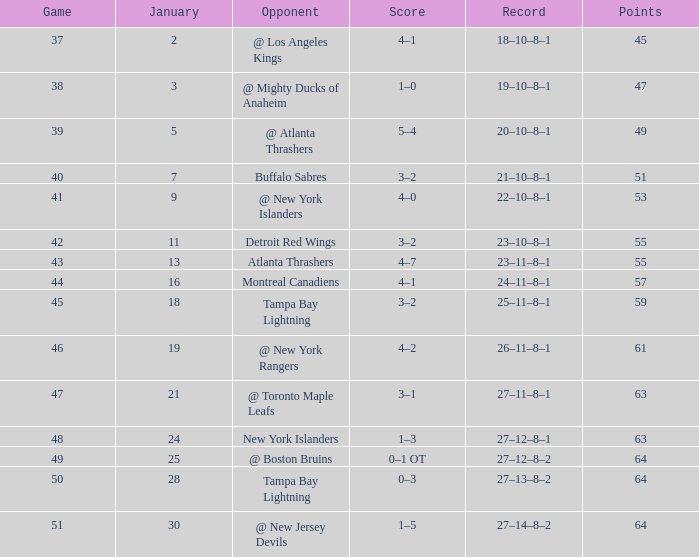Give me the full table as a dictionary. {'header': ['Game', 'January', 'Opponent', 'Score', 'Record', 'Points'], 'rows': [['37', '2', '@ Los Angeles Kings', '4–1', '18–10–8–1', '45'], ['38', '3', '@ Mighty Ducks of Anaheim', '1–0', '19–10–8–1', '47'], ['39', '5', '@ Atlanta Thrashers', '5–4', '20–10–8–1', '49'], ['40', '7', 'Buffalo Sabres', '3–2', '21–10–8–1', '51'], ['41', '9', '@ New York Islanders', '4–0', '22–10–8–1', '53'], ['42', '11', 'Detroit Red Wings', '3–2', '23–10–8–1', '55'], ['43', '13', 'Atlanta Thrashers', '4–7', '23–11–8–1', '55'], ['44', '16', 'Montreal Canadiens', '4–1', '24–11–8–1', '57'], ['45', '18', 'Tampa Bay Lightning', '3–2', '25–11–8–1', '59'], ['46', '19', '@ New York Rangers', '4–2', '26–11–8–1', '61'], ['47', '21', '@ Toronto Maple Leafs', '3–1', '27–11–8–1', '63'], ['48', '24', 'New York Islanders', '1–3', '27–12–8–1', '63'], ['49', '25', '@ Boston Bruins', '0–1 OT', '27–12–8–2', '64'], ['50', '28', 'Tampa Bay Lightning', '0–3', '27–13–8–2', '64'], ['51', '30', '@ New Jersey Devils', '1–5', '27–14–8–2', '64']]} Which Score has Points of 64, and a Game of 49? 0–1 OT. 